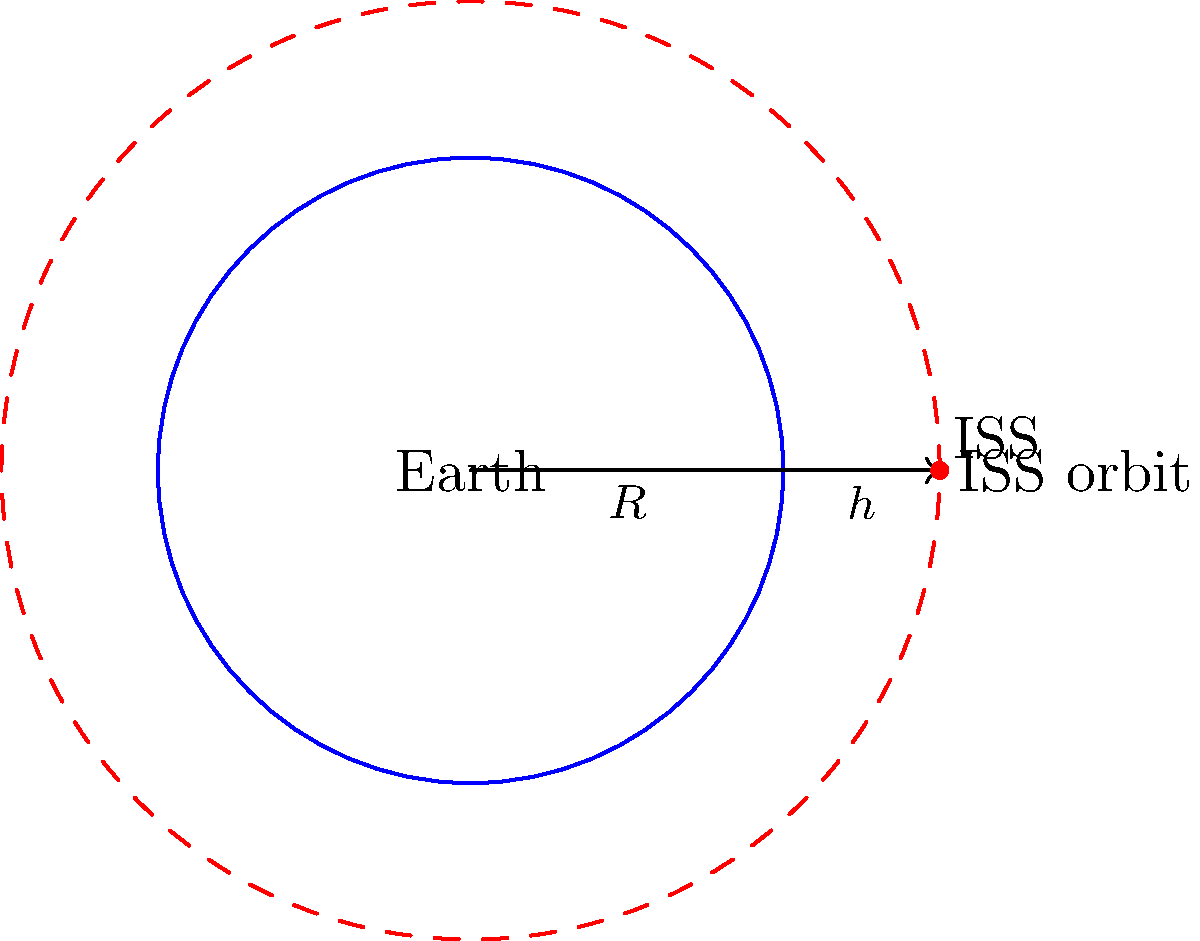As a former TV presenter who likely covered space-related news, you should be familiar with the International Space Station (ISS). If the ISS orbits at an altitude of approximately 400 km above Earth's surface, and Earth's radius is about 6,371 km, what is the orbital period of the ISS in minutes, rounded to the nearest whole number? Let's approach this step-by-step:

1) First, we need to use the orbital period formula:
   $$T = 2\pi\sqrt{\frac{r^3}{GM}}$$
   Where:
   $T$ is the orbital period
   $r$ is the orbital radius
   $G$ is the gravitational constant
   $M$ is the mass of Earth

2) We know the altitude of the ISS ($h$) and Earth's radius ($R$). The orbital radius is:
   $$r = R + h = 6,371 \text{ km} + 400 \text{ km} = 6,771 \text{ km}$$

3) We can simplify our calculation by using a derived formula for low Earth orbits:
   $$T = 2\pi\sqrt{\frac{r^3}{GM}} \approx 84.4\sqrt{r^3}$$
   (where $r$ is in meters and $T$ is in minutes)

4) Let's plug in our value for $r$:
   $$T \approx 84.4\sqrt{(6,771,000 \text{ m})^3}$$

5) Calculating:
   $$T \approx 84.4 \times 17,870,330 \approx 92.56 \text{ minutes}$$

6) Rounding to the nearest whole number:
   $$T \approx 93 \text{ minutes}$$
Answer: 93 minutes 